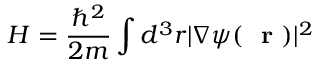<formula> <loc_0><loc_0><loc_500><loc_500>H = \frac { \hbar { ^ } { 2 } } { 2 m } \int d ^ { 3 } r | \nabla \psi ( r ) | ^ { 2 }</formula> 